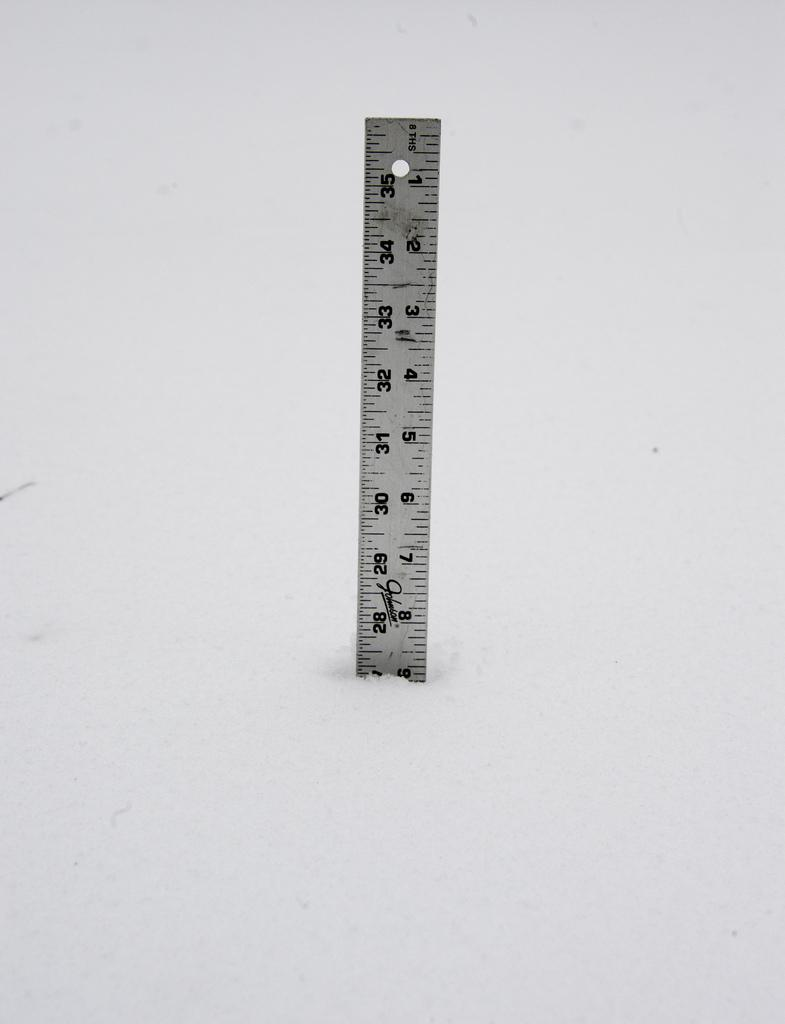<image>
Give a short and clear explanation of the subsequent image. Silver ruler from Johnson in front of a gray background. 